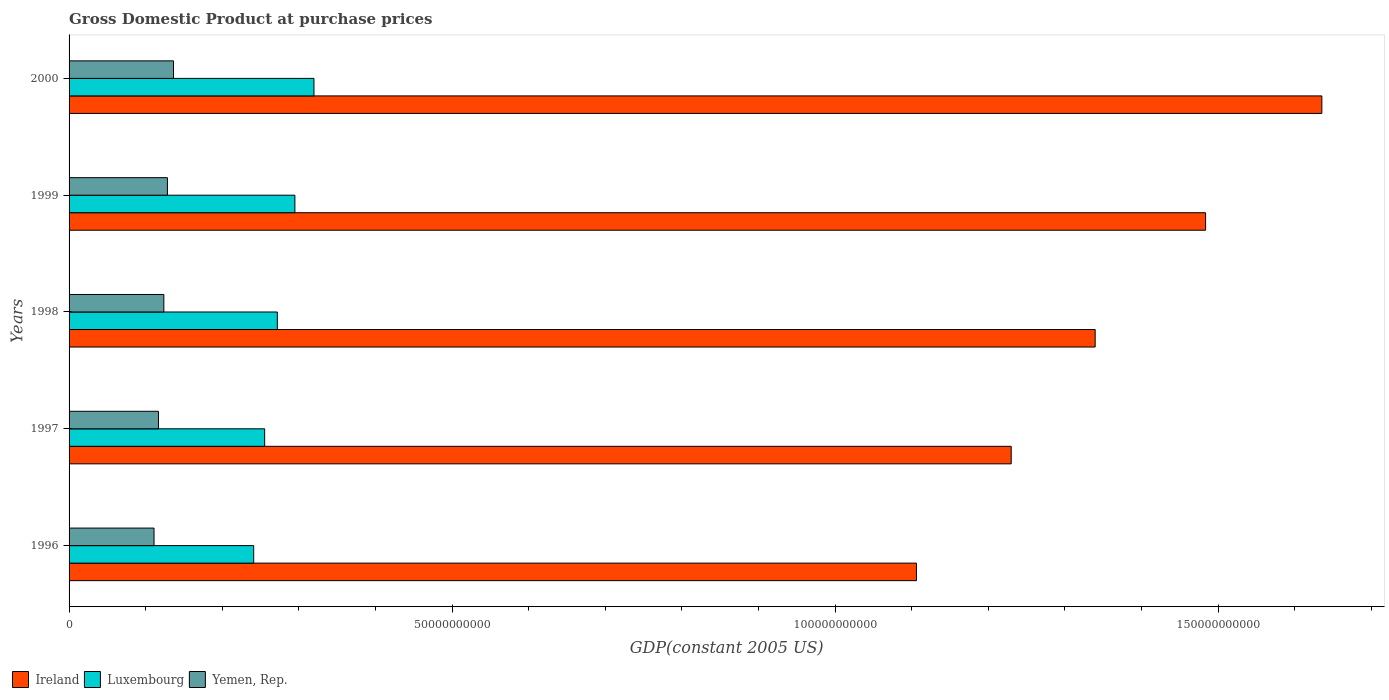How many groups of bars are there?
Your answer should be very brief. 5. In how many cases, is the number of bars for a given year not equal to the number of legend labels?
Ensure brevity in your answer.  0. What is the GDP at purchase prices in Yemen, Rep. in 2000?
Your answer should be compact. 1.36e+1. Across all years, what is the maximum GDP at purchase prices in Ireland?
Offer a terse response. 1.64e+11. Across all years, what is the minimum GDP at purchase prices in Ireland?
Keep it short and to the point. 1.11e+11. In which year was the GDP at purchase prices in Luxembourg minimum?
Make the answer very short. 1996. What is the total GDP at purchase prices in Yemen, Rep. in the graph?
Make the answer very short. 6.16e+1. What is the difference between the GDP at purchase prices in Yemen, Rep. in 1997 and that in 1999?
Keep it short and to the point. -1.17e+09. What is the difference between the GDP at purchase prices in Ireland in 1996 and the GDP at purchase prices in Luxembourg in 2000?
Offer a very short reply. 7.87e+1. What is the average GDP at purchase prices in Ireland per year?
Provide a short and direct response. 1.36e+11. In the year 1997, what is the difference between the GDP at purchase prices in Ireland and GDP at purchase prices in Yemen, Rep.?
Your response must be concise. 1.11e+11. What is the ratio of the GDP at purchase prices in Luxembourg in 1997 to that in 1999?
Make the answer very short. 0.87. Is the GDP at purchase prices in Ireland in 1998 less than that in 1999?
Give a very brief answer. Yes. Is the difference between the GDP at purchase prices in Ireland in 1997 and 2000 greater than the difference between the GDP at purchase prices in Yemen, Rep. in 1997 and 2000?
Your response must be concise. No. What is the difference between the highest and the second highest GDP at purchase prices in Ireland?
Your response must be concise. 1.52e+1. What is the difference between the highest and the lowest GDP at purchase prices in Yemen, Rep.?
Keep it short and to the point. 2.54e+09. In how many years, is the GDP at purchase prices in Ireland greater than the average GDP at purchase prices in Ireland taken over all years?
Ensure brevity in your answer.  2. Is the sum of the GDP at purchase prices in Yemen, Rep. in 1998 and 1999 greater than the maximum GDP at purchase prices in Ireland across all years?
Provide a succinct answer. No. What does the 2nd bar from the top in 1997 represents?
Your answer should be compact. Luxembourg. What does the 2nd bar from the bottom in 1996 represents?
Ensure brevity in your answer.  Luxembourg. Is it the case that in every year, the sum of the GDP at purchase prices in Yemen, Rep. and GDP at purchase prices in Ireland is greater than the GDP at purchase prices in Luxembourg?
Give a very brief answer. Yes. How many bars are there?
Ensure brevity in your answer.  15. How many years are there in the graph?
Give a very brief answer. 5. What is the difference between two consecutive major ticks on the X-axis?
Your answer should be compact. 5.00e+1. Where does the legend appear in the graph?
Keep it short and to the point. Bottom left. How many legend labels are there?
Give a very brief answer. 3. What is the title of the graph?
Keep it short and to the point. Gross Domestic Product at purchase prices. Does "Angola" appear as one of the legend labels in the graph?
Your answer should be very brief. No. What is the label or title of the X-axis?
Provide a succinct answer. GDP(constant 2005 US). What is the GDP(constant 2005 US) in Ireland in 1996?
Your response must be concise. 1.11e+11. What is the GDP(constant 2005 US) of Luxembourg in 1996?
Your response must be concise. 2.41e+1. What is the GDP(constant 2005 US) of Yemen, Rep. in 1996?
Provide a succinct answer. 1.11e+1. What is the GDP(constant 2005 US) of Ireland in 1997?
Keep it short and to the point. 1.23e+11. What is the GDP(constant 2005 US) of Luxembourg in 1997?
Keep it short and to the point. 2.55e+1. What is the GDP(constant 2005 US) of Yemen, Rep. in 1997?
Make the answer very short. 1.17e+1. What is the GDP(constant 2005 US) of Ireland in 1998?
Provide a succinct answer. 1.34e+11. What is the GDP(constant 2005 US) of Luxembourg in 1998?
Your response must be concise. 2.72e+1. What is the GDP(constant 2005 US) of Yemen, Rep. in 1998?
Ensure brevity in your answer.  1.24e+1. What is the GDP(constant 2005 US) in Ireland in 1999?
Keep it short and to the point. 1.48e+11. What is the GDP(constant 2005 US) in Luxembourg in 1999?
Offer a terse response. 2.95e+1. What is the GDP(constant 2005 US) in Yemen, Rep. in 1999?
Provide a succinct answer. 1.28e+1. What is the GDP(constant 2005 US) in Ireland in 2000?
Keep it short and to the point. 1.64e+11. What is the GDP(constant 2005 US) of Luxembourg in 2000?
Your response must be concise. 3.20e+1. What is the GDP(constant 2005 US) of Yemen, Rep. in 2000?
Your answer should be compact. 1.36e+1. Across all years, what is the maximum GDP(constant 2005 US) of Ireland?
Your response must be concise. 1.64e+11. Across all years, what is the maximum GDP(constant 2005 US) of Luxembourg?
Offer a very short reply. 3.20e+1. Across all years, what is the maximum GDP(constant 2005 US) of Yemen, Rep.?
Provide a succinct answer. 1.36e+1. Across all years, what is the minimum GDP(constant 2005 US) in Ireland?
Keep it short and to the point. 1.11e+11. Across all years, what is the minimum GDP(constant 2005 US) in Luxembourg?
Keep it short and to the point. 2.41e+1. Across all years, what is the minimum GDP(constant 2005 US) in Yemen, Rep.?
Ensure brevity in your answer.  1.11e+1. What is the total GDP(constant 2005 US) in Ireland in the graph?
Offer a very short reply. 6.79e+11. What is the total GDP(constant 2005 US) in Luxembourg in the graph?
Provide a succinct answer. 1.38e+11. What is the total GDP(constant 2005 US) in Yemen, Rep. in the graph?
Make the answer very short. 6.16e+1. What is the difference between the GDP(constant 2005 US) in Ireland in 1996 and that in 1997?
Ensure brevity in your answer.  -1.24e+1. What is the difference between the GDP(constant 2005 US) in Luxembourg in 1996 and that in 1997?
Offer a very short reply. -1.43e+09. What is the difference between the GDP(constant 2005 US) of Yemen, Rep. in 1996 and that in 1997?
Provide a succinct answer. -5.80e+08. What is the difference between the GDP(constant 2005 US) in Ireland in 1996 and that in 1998?
Make the answer very short. -2.33e+1. What is the difference between the GDP(constant 2005 US) in Luxembourg in 1996 and that in 1998?
Provide a short and direct response. -3.09e+09. What is the difference between the GDP(constant 2005 US) of Yemen, Rep. in 1996 and that in 1998?
Your response must be concise. -1.28e+09. What is the difference between the GDP(constant 2005 US) in Ireland in 1996 and that in 1999?
Provide a succinct answer. -3.77e+1. What is the difference between the GDP(constant 2005 US) of Luxembourg in 1996 and that in 1999?
Ensure brevity in your answer.  -5.38e+09. What is the difference between the GDP(constant 2005 US) of Yemen, Rep. in 1996 and that in 1999?
Give a very brief answer. -1.75e+09. What is the difference between the GDP(constant 2005 US) in Ireland in 1996 and that in 2000?
Your response must be concise. -5.29e+1. What is the difference between the GDP(constant 2005 US) in Luxembourg in 1996 and that in 2000?
Ensure brevity in your answer.  -7.87e+09. What is the difference between the GDP(constant 2005 US) of Yemen, Rep. in 1996 and that in 2000?
Give a very brief answer. -2.54e+09. What is the difference between the GDP(constant 2005 US) in Ireland in 1997 and that in 1998?
Give a very brief answer. -1.10e+1. What is the difference between the GDP(constant 2005 US) of Luxembourg in 1997 and that in 1998?
Your answer should be compact. -1.66e+09. What is the difference between the GDP(constant 2005 US) of Yemen, Rep. in 1997 and that in 1998?
Your answer should be very brief. -7.01e+08. What is the difference between the GDP(constant 2005 US) in Ireland in 1997 and that in 1999?
Offer a very short reply. -2.54e+1. What is the difference between the GDP(constant 2005 US) of Luxembourg in 1997 and that in 1999?
Provide a short and direct response. -3.95e+09. What is the difference between the GDP(constant 2005 US) of Yemen, Rep. in 1997 and that in 1999?
Your response must be concise. -1.17e+09. What is the difference between the GDP(constant 2005 US) of Ireland in 1997 and that in 2000?
Your answer should be very brief. -4.06e+1. What is the difference between the GDP(constant 2005 US) in Luxembourg in 1997 and that in 2000?
Make the answer very short. -6.44e+09. What is the difference between the GDP(constant 2005 US) of Yemen, Rep. in 1997 and that in 2000?
Your answer should be very brief. -1.96e+09. What is the difference between the GDP(constant 2005 US) of Ireland in 1998 and that in 1999?
Provide a short and direct response. -1.44e+1. What is the difference between the GDP(constant 2005 US) in Luxembourg in 1998 and that in 1999?
Offer a very short reply. -2.29e+09. What is the difference between the GDP(constant 2005 US) of Yemen, Rep. in 1998 and that in 1999?
Offer a very short reply. -4.67e+08. What is the difference between the GDP(constant 2005 US) of Ireland in 1998 and that in 2000?
Offer a terse response. -2.96e+1. What is the difference between the GDP(constant 2005 US) in Luxembourg in 1998 and that in 2000?
Your response must be concise. -4.78e+09. What is the difference between the GDP(constant 2005 US) in Yemen, Rep. in 1998 and that in 2000?
Keep it short and to the point. -1.26e+09. What is the difference between the GDP(constant 2005 US) of Ireland in 1999 and that in 2000?
Make the answer very short. -1.52e+1. What is the difference between the GDP(constant 2005 US) of Luxembourg in 1999 and that in 2000?
Provide a short and direct response. -2.49e+09. What is the difference between the GDP(constant 2005 US) in Yemen, Rep. in 1999 and that in 2000?
Keep it short and to the point. -7.94e+08. What is the difference between the GDP(constant 2005 US) of Ireland in 1996 and the GDP(constant 2005 US) of Luxembourg in 1997?
Your response must be concise. 8.51e+1. What is the difference between the GDP(constant 2005 US) of Ireland in 1996 and the GDP(constant 2005 US) of Yemen, Rep. in 1997?
Ensure brevity in your answer.  9.90e+1. What is the difference between the GDP(constant 2005 US) in Luxembourg in 1996 and the GDP(constant 2005 US) in Yemen, Rep. in 1997?
Offer a very short reply. 1.24e+1. What is the difference between the GDP(constant 2005 US) in Ireland in 1996 and the GDP(constant 2005 US) in Luxembourg in 1998?
Provide a succinct answer. 8.34e+1. What is the difference between the GDP(constant 2005 US) in Ireland in 1996 and the GDP(constant 2005 US) in Yemen, Rep. in 1998?
Offer a very short reply. 9.83e+1. What is the difference between the GDP(constant 2005 US) in Luxembourg in 1996 and the GDP(constant 2005 US) in Yemen, Rep. in 1998?
Your answer should be compact. 1.17e+1. What is the difference between the GDP(constant 2005 US) of Ireland in 1996 and the GDP(constant 2005 US) of Luxembourg in 1999?
Your answer should be compact. 8.11e+1. What is the difference between the GDP(constant 2005 US) in Ireland in 1996 and the GDP(constant 2005 US) in Yemen, Rep. in 1999?
Your answer should be very brief. 9.78e+1. What is the difference between the GDP(constant 2005 US) of Luxembourg in 1996 and the GDP(constant 2005 US) of Yemen, Rep. in 1999?
Your answer should be compact. 1.13e+1. What is the difference between the GDP(constant 2005 US) in Ireland in 1996 and the GDP(constant 2005 US) in Luxembourg in 2000?
Keep it short and to the point. 7.87e+1. What is the difference between the GDP(constant 2005 US) of Ireland in 1996 and the GDP(constant 2005 US) of Yemen, Rep. in 2000?
Ensure brevity in your answer.  9.70e+1. What is the difference between the GDP(constant 2005 US) in Luxembourg in 1996 and the GDP(constant 2005 US) in Yemen, Rep. in 2000?
Offer a terse response. 1.05e+1. What is the difference between the GDP(constant 2005 US) of Ireland in 1997 and the GDP(constant 2005 US) of Luxembourg in 1998?
Offer a terse response. 9.58e+1. What is the difference between the GDP(constant 2005 US) of Ireland in 1997 and the GDP(constant 2005 US) of Yemen, Rep. in 1998?
Give a very brief answer. 1.11e+11. What is the difference between the GDP(constant 2005 US) in Luxembourg in 1997 and the GDP(constant 2005 US) in Yemen, Rep. in 1998?
Provide a succinct answer. 1.32e+1. What is the difference between the GDP(constant 2005 US) in Ireland in 1997 and the GDP(constant 2005 US) in Luxembourg in 1999?
Offer a terse response. 9.35e+1. What is the difference between the GDP(constant 2005 US) of Ireland in 1997 and the GDP(constant 2005 US) of Yemen, Rep. in 1999?
Make the answer very short. 1.10e+11. What is the difference between the GDP(constant 2005 US) of Luxembourg in 1997 and the GDP(constant 2005 US) of Yemen, Rep. in 1999?
Provide a short and direct response. 1.27e+1. What is the difference between the GDP(constant 2005 US) of Ireland in 1997 and the GDP(constant 2005 US) of Luxembourg in 2000?
Provide a short and direct response. 9.10e+1. What is the difference between the GDP(constant 2005 US) in Ireland in 1997 and the GDP(constant 2005 US) in Yemen, Rep. in 2000?
Your answer should be very brief. 1.09e+11. What is the difference between the GDP(constant 2005 US) of Luxembourg in 1997 and the GDP(constant 2005 US) of Yemen, Rep. in 2000?
Your response must be concise. 1.19e+1. What is the difference between the GDP(constant 2005 US) of Ireland in 1998 and the GDP(constant 2005 US) of Luxembourg in 1999?
Offer a terse response. 1.04e+11. What is the difference between the GDP(constant 2005 US) in Ireland in 1998 and the GDP(constant 2005 US) in Yemen, Rep. in 1999?
Make the answer very short. 1.21e+11. What is the difference between the GDP(constant 2005 US) of Luxembourg in 1998 and the GDP(constant 2005 US) of Yemen, Rep. in 1999?
Offer a very short reply. 1.44e+1. What is the difference between the GDP(constant 2005 US) in Ireland in 1998 and the GDP(constant 2005 US) in Luxembourg in 2000?
Give a very brief answer. 1.02e+11. What is the difference between the GDP(constant 2005 US) of Ireland in 1998 and the GDP(constant 2005 US) of Yemen, Rep. in 2000?
Your answer should be very brief. 1.20e+11. What is the difference between the GDP(constant 2005 US) of Luxembourg in 1998 and the GDP(constant 2005 US) of Yemen, Rep. in 2000?
Offer a terse response. 1.36e+1. What is the difference between the GDP(constant 2005 US) in Ireland in 1999 and the GDP(constant 2005 US) in Luxembourg in 2000?
Provide a short and direct response. 1.16e+11. What is the difference between the GDP(constant 2005 US) in Ireland in 1999 and the GDP(constant 2005 US) in Yemen, Rep. in 2000?
Make the answer very short. 1.35e+11. What is the difference between the GDP(constant 2005 US) in Luxembourg in 1999 and the GDP(constant 2005 US) in Yemen, Rep. in 2000?
Provide a succinct answer. 1.58e+1. What is the average GDP(constant 2005 US) in Ireland per year?
Provide a succinct answer. 1.36e+11. What is the average GDP(constant 2005 US) of Luxembourg per year?
Offer a very short reply. 2.77e+1. What is the average GDP(constant 2005 US) of Yemen, Rep. per year?
Your answer should be very brief. 1.23e+1. In the year 1996, what is the difference between the GDP(constant 2005 US) of Ireland and GDP(constant 2005 US) of Luxembourg?
Provide a succinct answer. 8.65e+1. In the year 1996, what is the difference between the GDP(constant 2005 US) in Ireland and GDP(constant 2005 US) in Yemen, Rep.?
Provide a short and direct response. 9.95e+1. In the year 1996, what is the difference between the GDP(constant 2005 US) in Luxembourg and GDP(constant 2005 US) in Yemen, Rep.?
Your response must be concise. 1.30e+1. In the year 1997, what is the difference between the GDP(constant 2005 US) of Ireland and GDP(constant 2005 US) of Luxembourg?
Your answer should be very brief. 9.75e+1. In the year 1997, what is the difference between the GDP(constant 2005 US) of Ireland and GDP(constant 2005 US) of Yemen, Rep.?
Your response must be concise. 1.11e+11. In the year 1997, what is the difference between the GDP(constant 2005 US) in Luxembourg and GDP(constant 2005 US) in Yemen, Rep.?
Your answer should be very brief. 1.39e+1. In the year 1998, what is the difference between the GDP(constant 2005 US) of Ireland and GDP(constant 2005 US) of Luxembourg?
Your answer should be very brief. 1.07e+11. In the year 1998, what is the difference between the GDP(constant 2005 US) of Ireland and GDP(constant 2005 US) of Yemen, Rep.?
Provide a succinct answer. 1.22e+11. In the year 1998, what is the difference between the GDP(constant 2005 US) of Luxembourg and GDP(constant 2005 US) of Yemen, Rep.?
Your answer should be compact. 1.48e+1. In the year 1999, what is the difference between the GDP(constant 2005 US) of Ireland and GDP(constant 2005 US) of Luxembourg?
Offer a terse response. 1.19e+11. In the year 1999, what is the difference between the GDP(constant 2005 US) of Ireland and GDP(constant 2005 US) of Yemen, Rep.?
Your answer should be very brief. 1.36e+11. In the year 1999, what is the difference between the GDP(constant 2005 US) in Luxembourg and GDP(constant 2005 US) in Yemen, Rep.?
Provide a short and direct response. 1.66e+1. In the year 2000, what is the difference between the GDP(constant 2005 US) in Ireland and GDP(constant 2005 US) in Luxembourg?
Offer a very short reply. 1.32e+11. In the year 2000, what is the difference between the GDP(constant 2005 US) of Ireland and GDP(constant 2005 US) of Yemen, Rep.?
Offer a very short reply. 1.50e+11. In the year 2000, what is the difference between the GDP(constant 2005 US) of Luxembourg and GDP(constant 2005 US) of Yemen, Rep.?
Offer a very short reply. 1.83e+1. What is the ratio of the GDP(constant 2005 US) in Ireland in 1996 to that in 1997?
Your response must be concise. 0.9. What is the ratio of the GDP(constant 2005 US) of Luxembourg in 1996 to that in 1997?
Keep it short and to the point. 0.94. What is the ratio of the GDP(constant 2005 US) in Yemen, Rep. in 1996 to that in 1997?
Offer a terse response. 0.95. What is the ratio of the GDP(constant 2005 US) of Ireland in 1996 to that in 1998?
Offer a terse response. 0.83. What is the ratio of the GDP(constant 2005 US) in Luxembourg in 1996 to that in 1998?
Give a very brief answer. 0.89. What is the ratio of the GDP(constant 2005 US) of Yemen, Rep. in 1996 to that in 1998?
Offer a terse response. 0.9. What is the ratio of the GDP(constant 2005 US) of Ireland in 1996 to that in 1999?
Your response must be concise. 0.75. What is the ratio of the GDP(constant 2005 US) of Luxembourg in 1996 to that in 1999?
Your response must be concise. 0.82. What is the ratio of the GDP(constant 2005 US) of Yemen, Rep. in 1996 to that in 1999?
Ensure brevity in your answer.  0.86. What is the ratio of the GDP(constant 2005 US) of Ireland in 1996 to that in 2000?
Provide a short and direct response. 0.68. What is the ratio of the GDP(constant 2005 US) of Luxembourg in 1996 to that in 2000?
Your answer should be very brief. 0.75. What is the ratio of the GDP(constant 2005 US) of Yemen, Rep. in 1996 to that in 2000?
Keep it short and to the point. 0.81. What is the ratio of the GDP(constant 2005 US) in Ireland in 1997 to that in 1998?
Make the answer very short. 0.92. What is the ratio of the GDP(constant 2005 US) of Luxembourg in 1997 to that in 1998?
Give a very brief answer. 0.94. What is the ratio of the GDP(constant 2005 US) of Yemen, Rep. in 1997 to that in 1998?
Your answer should be very brief. 0.94. What is the ratio of the GDP(constant 2005 US) of Ireland in 1997 to that in 1999?
Your answer should be very brief. 0.83. What is the ratio of the GDP(constant 2005 US) in Luxembourg in 1997 to that in 1999?
Your answer should be very brief. 0.87. What is the ratio of the GDP(constant 2005 US) in Yemen, Rep. in 1997 to that in 1999?
Make the answer very short. 0.91. What is the ratio of the GDP(constant 2005 US) in Ireland in 1997 to that in 2000?
Make the answer very short. 0.75. What is the ratio of the GDP(constant 2005 US) of Luxembourg in 1997 to that in 2000?
Give a very brief answer. 0.8. What is the ratio of the GDP(constant 2005 US) in Yemen, Rep. in 1997 to that in 2000?
Your answer should be very brief. 0.86. What is the ratio of the GDP(constant 2005 US) of Ireland in 1998 to that in 1999?
Give a very brief answer. 0.9. What is the ratio of the GDP(constant 2005 US) in Luxembourg in 1998 to that in 1999?
Offer a very short reply. 0.92. What is the ratio of the GDP(constant 2005 US) in Yemen, Rep. in 1998 to that in 1999?
Keep it short and to the point. 0.96. What is the ratio of the GDP(constant 2005 US) in Ireland in 1998 to that in 2000?
Make the answer very short. 0.82. What is the ratio of the GDP(constant 2005 US) of Luxembourg in 1998 to that in 2000?
Ensure brevity in your answer.  0.85. What is the ratio of the GDP(constant 2005 US) of Yemen, Rep. in 1998 to that in 2000?
Give a very brief answer. 0.91. What is the ratio of the GDP(constant 2005 US) in Ireland in 1999 to that in 2000?
Provide a short and direct response. 0.91. What is the ratio of the GDP(constant 2005 US) of Luxembourg in 1999 to that in 2000?
Provide a succinct answer. 0.92. What is the ratio of the GDP(constant 2005 US) in Yemen, Rep. in 1999 to that in 2000?
Offer a terse response. 0.94. What is the difference between the highest and the second highest GDP(constant 2005 US) of Ireland?
Make the answer very short. 1.52e+1. What is the difference between the highest and the second highest GDP(constant 2005 US) in Luxembourg?
Give a very brief answer. 2.49e+09. What is the difference between the highest and the second highest GDP(constant 2005 US) in Yemen, Rep.?
Provide a short and direct response. 7.94e+08. What is the difference between the highest and the lowest GDP(constant 2005 US) in Ireland?
Provide a short and direct response. 5.29e+1. What is the difference between the highest and the lowest GDP(constant 2005 US) in Luxembourg?
Give a very brief answer. 7.87e+09. What is the difference between the highest and the lowest GDP(constant 2005 US) in Yemen, Rep.?
Offer a terse response. 2.54e+09. 